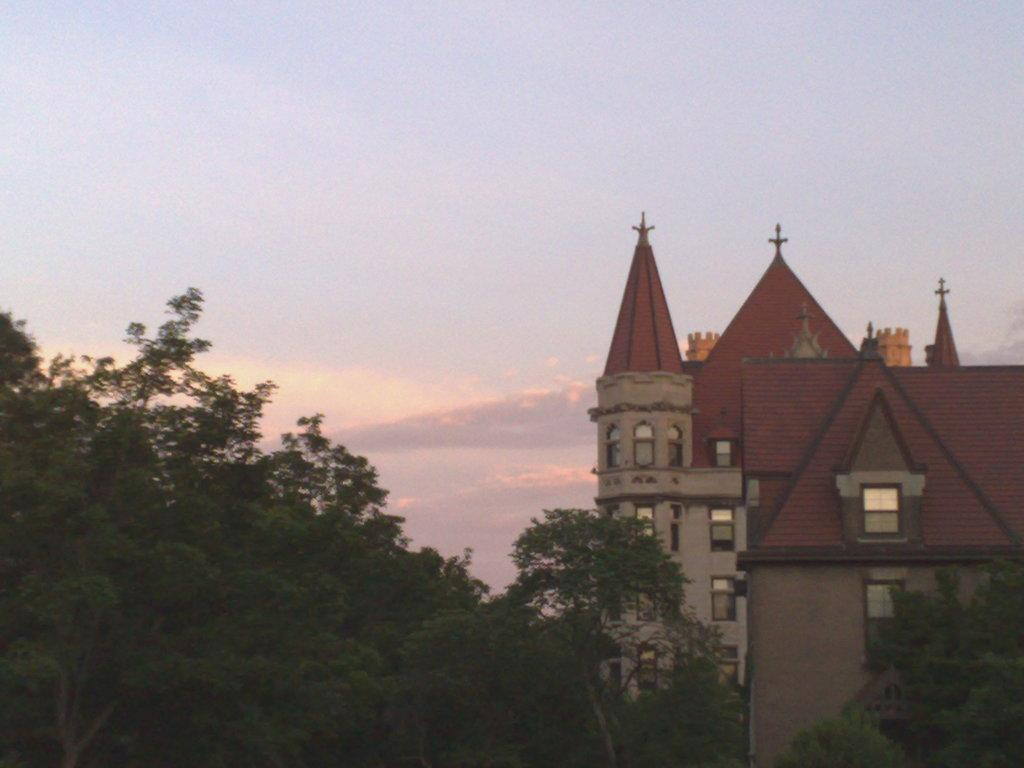What type of structures can be seen in the image? There are buildings in the image. What other natural elements are present in the image? There are trees in the image. How would you describe the sky in the image? The sky is blue and cloudy in the image. What type of laborer can be seen working in the image? There are no laborers present in the image; it only features buildings, trees, and a blue, cloudy sky. 